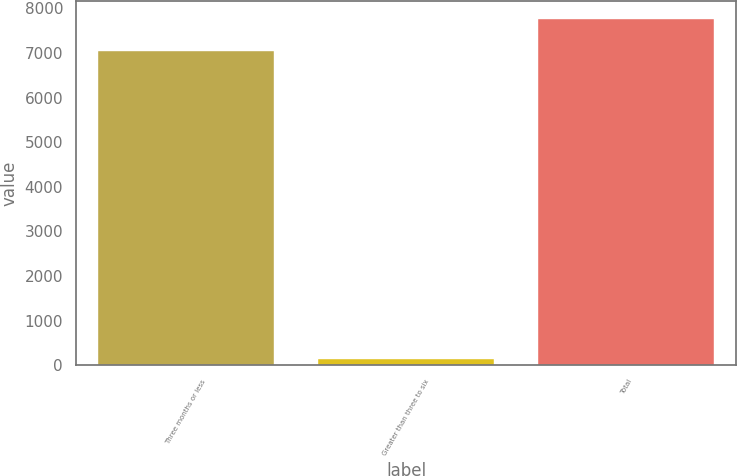<chart> <loc_0><loc_0><loc_500><loc_500><bar_chart><fcel>Three months or less<fcel>Greater than three to six<fcel>Total<nl><fcel>7044<fcel>150<fcel>7773<nl></chart> 